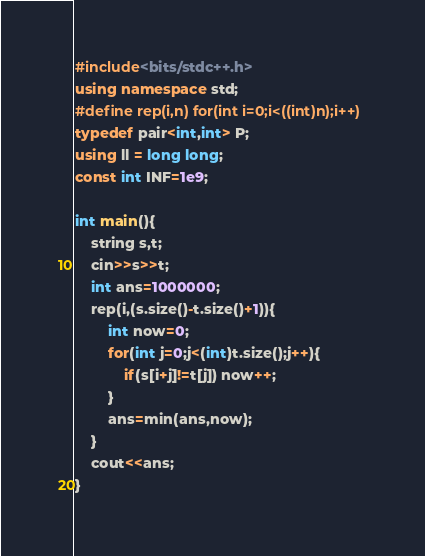Convert code to text. <code><loc_0><loc_0><loc_500><loc_500><_C++_>#include<bits/stdc++.h>
using namespace std;
#define rep(i,n) for(int i=0;i<((int)n);i++)
typedef pair<int,int> P;
using ll = long long;
const int INF=1e9;

int main(){
    string s,t;
    cin>>s>>t;
    int ans=1000000;
    rep(i,(s.size()-t.size()+1)){
        int now=0;
        for(int j=0;j<(int)t.size();j++){
            if(s[i+j]!=t[j]) now++;
        }
        ans=min(ans,now);
    }
    cout<<ans;
}</code> 